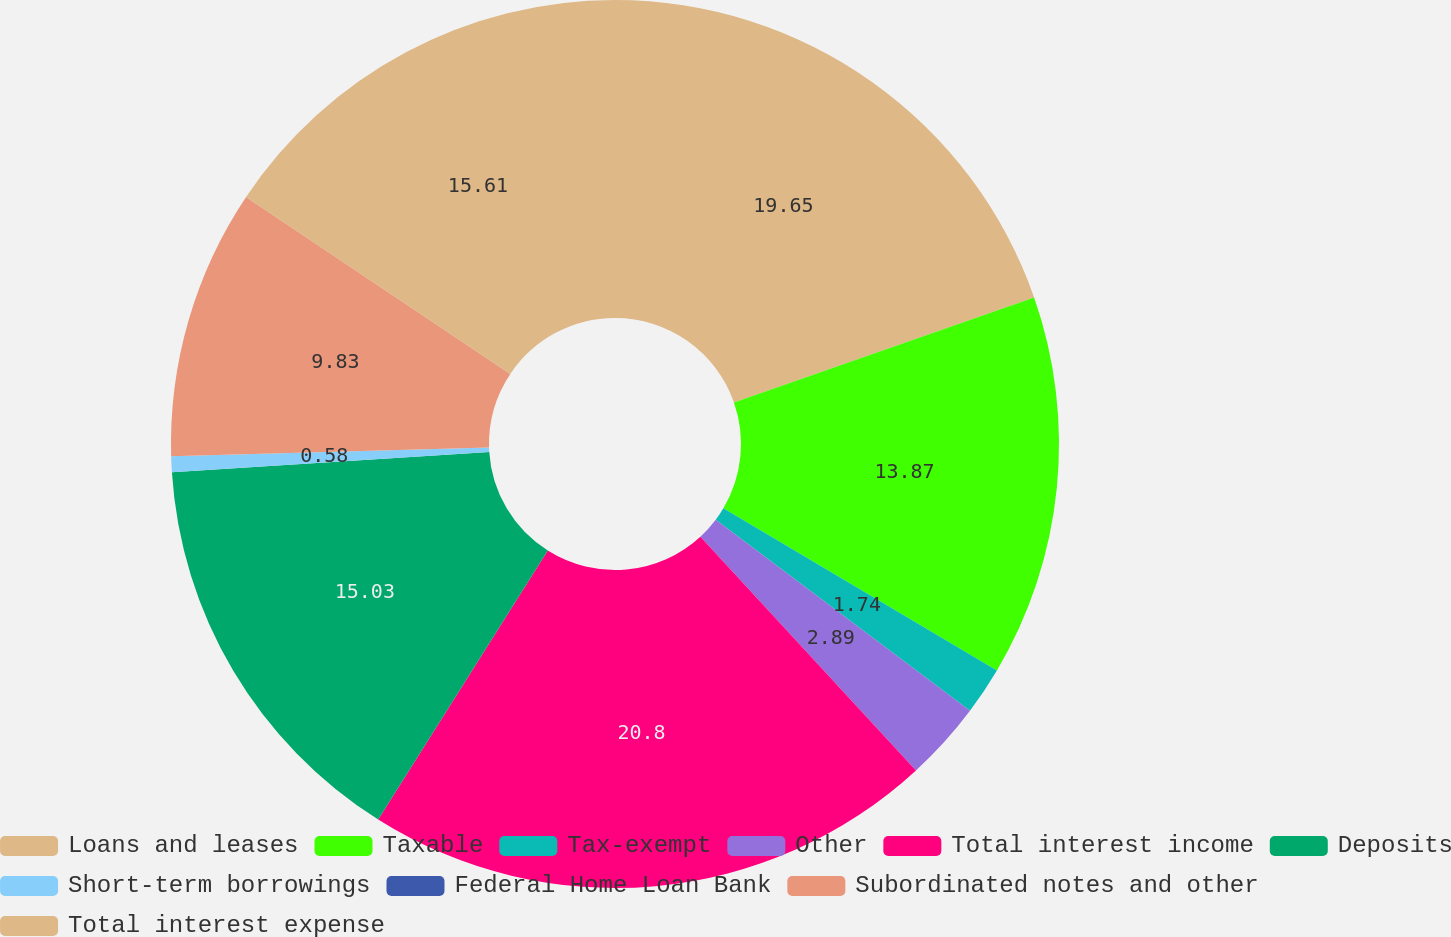Convert chart to OTSL. <chart><loc_0><loc_0><loc_500><loc_500><pie_chart><fcel>Loans and leases<fcel>Taxable<fcel>Tax-exempt<fcel>Other<fcel>Total interest income<fcel>Deposits<fcel>Short-term borrowings<fcel>Federal Home Loan Bank<fcel>Subordinated notes and other<fcel>Total interest expense<nl><fcel>19.65%<fcel>13.87%<fcel>1.74%<fcel>2.89%<fcel>20.81%<fcel>15.03%<fcel>0.58%<fcel>0.0%<fcel>9.83%<fcel>15.61%<nl></chart> 